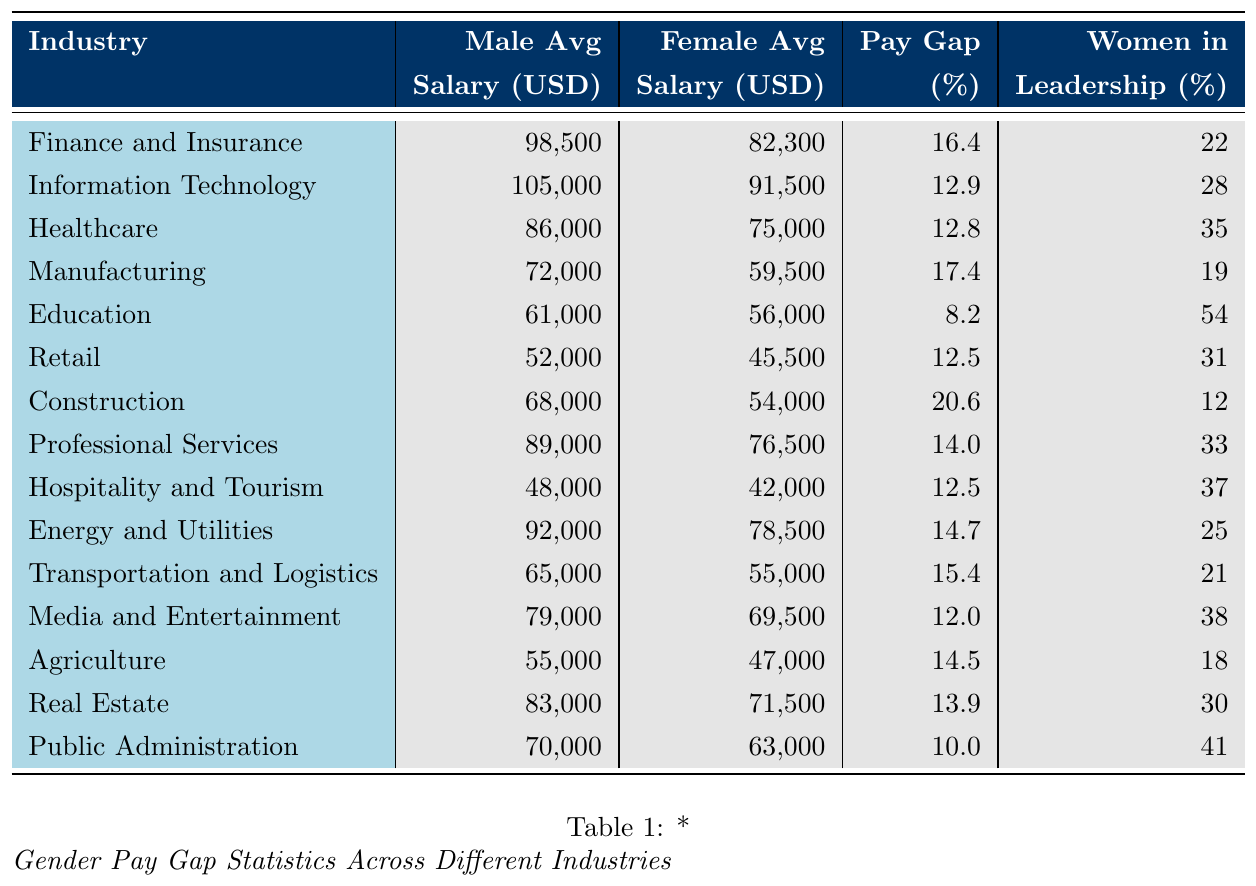What is the pay gap percentage in the Education industry? According to the table, the pay gap percentage in the Education industry is listed as 8.2%.
Answer: 8.2% Which industry has the highest average male salary? The Finance and Insurance industry has the highest average male salary at 98,500 USD.
Answer: 98,500 USD What is the average female salary in the Healthcare industry? The table indicates that the average female salary in the Healthcare industry is 75,000 USD.
Answer: 75,000 USD Is the pay gap in the Construction industry higher than 15%? The pay gap in the Construction industry is reported as 20.6%, which is indeed higher than 15%.
Answer: Yes What is the difference between the average male salary and the average female salary in the Professional Services industry? The average male salary is 89,000 USD, and the average female salary is 76,500 USD. The difference is calculated as 89,000 - 76,500 = 12,500 USD.
Answer: 12,500 USD Which industry has a pay gap of less than 13%? By reviewing the table, the only industry with a pay gap of less than 13% is Education at 8.2%.
Answer: Education What is the average pay gap percentage across all industries listed? To find the average pay gap percentage, sum the pay gap percentages (16.4 + 12.9 + 12.8 + 17.4 + 8.2 + 12.5 + 20.6 + 14.0 + 12.5 + 14.7 + 15.4 + 12.0 + 14.5 + 13.9 + 10.0) =  21% (sum) / 15 (industries) = 14.07%.
Answer: Approximately 14.07% How many industries have more than 30% of women in leadership? According to the table, the industries with more than 30% of women in leadership are Education (54%), Healthcare (35%), Hospitality and Tourism (37%), Media and Entertainment (38%), and Public Administration (41%). Thus, there are 5 industries with this characteristic.
Answer: 5 Which industry has the lowest average female salary and what is it? The industry with the lowest average female salary is Hospitality and Tourism, which has an average salary of 42,000 USD.
Answer: 42,000 USD Is the pay gap greater in the Manufacturing industry compared to the Healthcare industry? The Manufacturing industry has a pay gap of 17.4%, while the Healthcare industry has a pay gap of 12.8%. Therefore, yes, the pay gap is greater in the Manufacturing industry.
Answer: Yes What percentage of women are in leadership roles in the Retail industry? The table shows that 31% of women hold leadership roles in the Retail industry.
Answer: 31% 